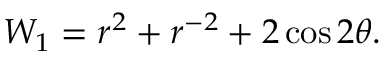Convert formula to latex. <formula><loc_0><loc_0><loc_500><loc_500>\begin{array} { r } { W _ { 1 } = r ^ { 2 } + r ^ { - 2 } + 2 \cos 2 \theta . } \end{array}</formula> 